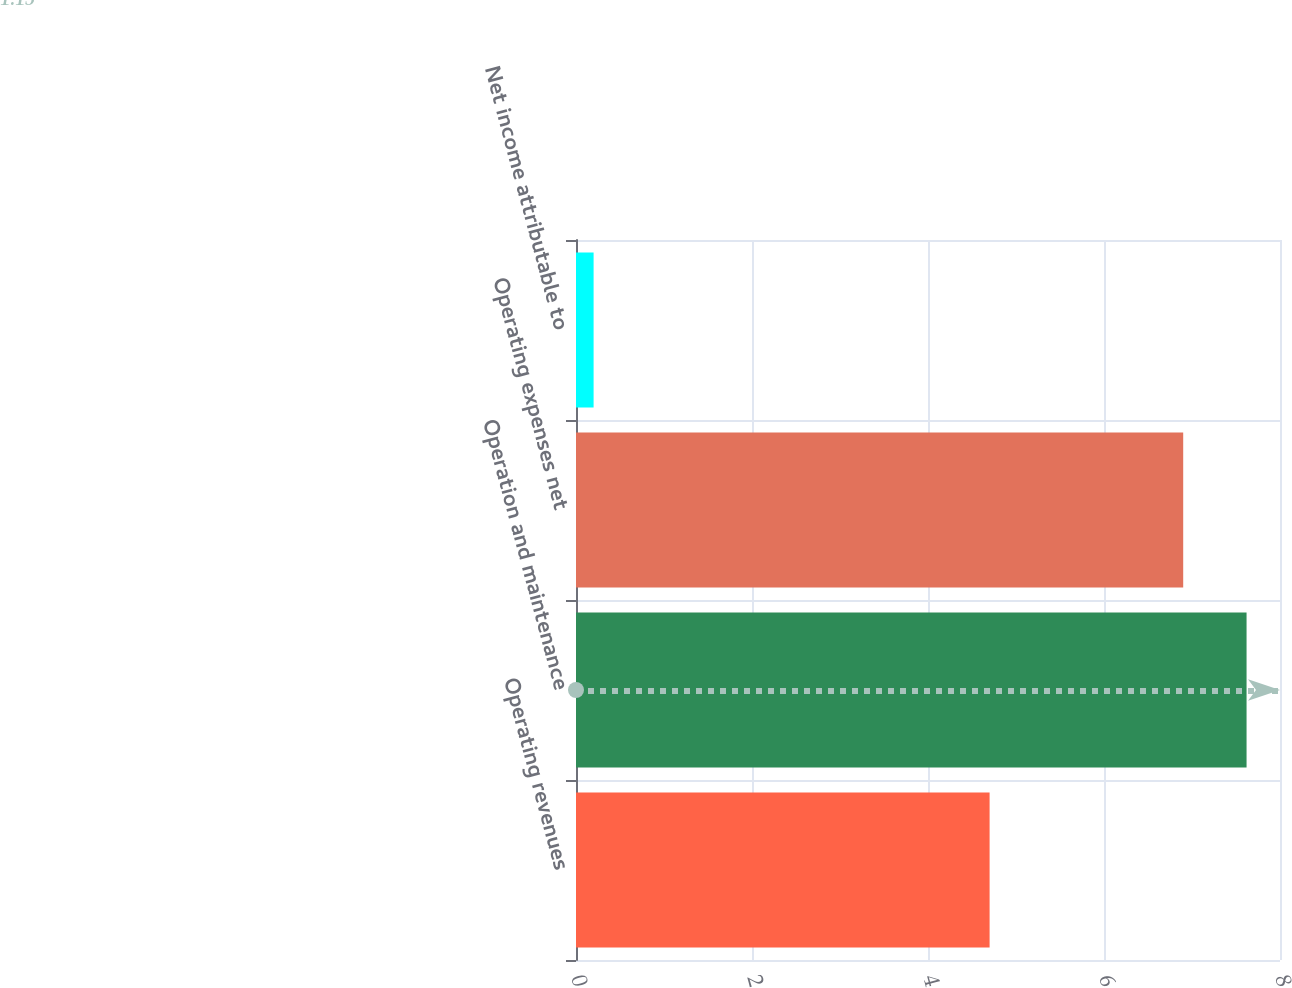<chart> <loc_0><loc_0><loc_500><loc_500><bar_chart><fcel>Operating revenues<fcel>Operation and maintenance<fcel>Operating expenses net<fcel>Net income attributable to<nl><fcel>4.7<fcel>7.62<fcel>6.9<fcel>0.2<nl></chart> 